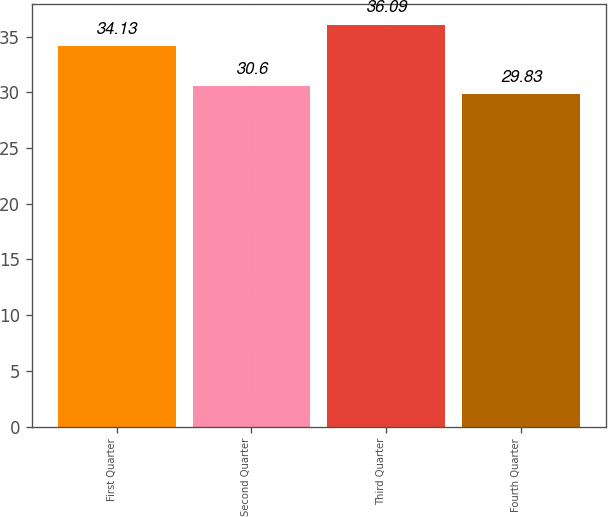Convert chart. <chart><loc_0><loc_0><loc_500><loc_500><bar_chart><fcel>First Quarter<fcel>Second Quarter<fcel>Third Quarter<fcel>Fourth Quarter<nl><fcel>34.13<fcel>30.6<fcel>36.09<fcel>29.83<nl></chart> 